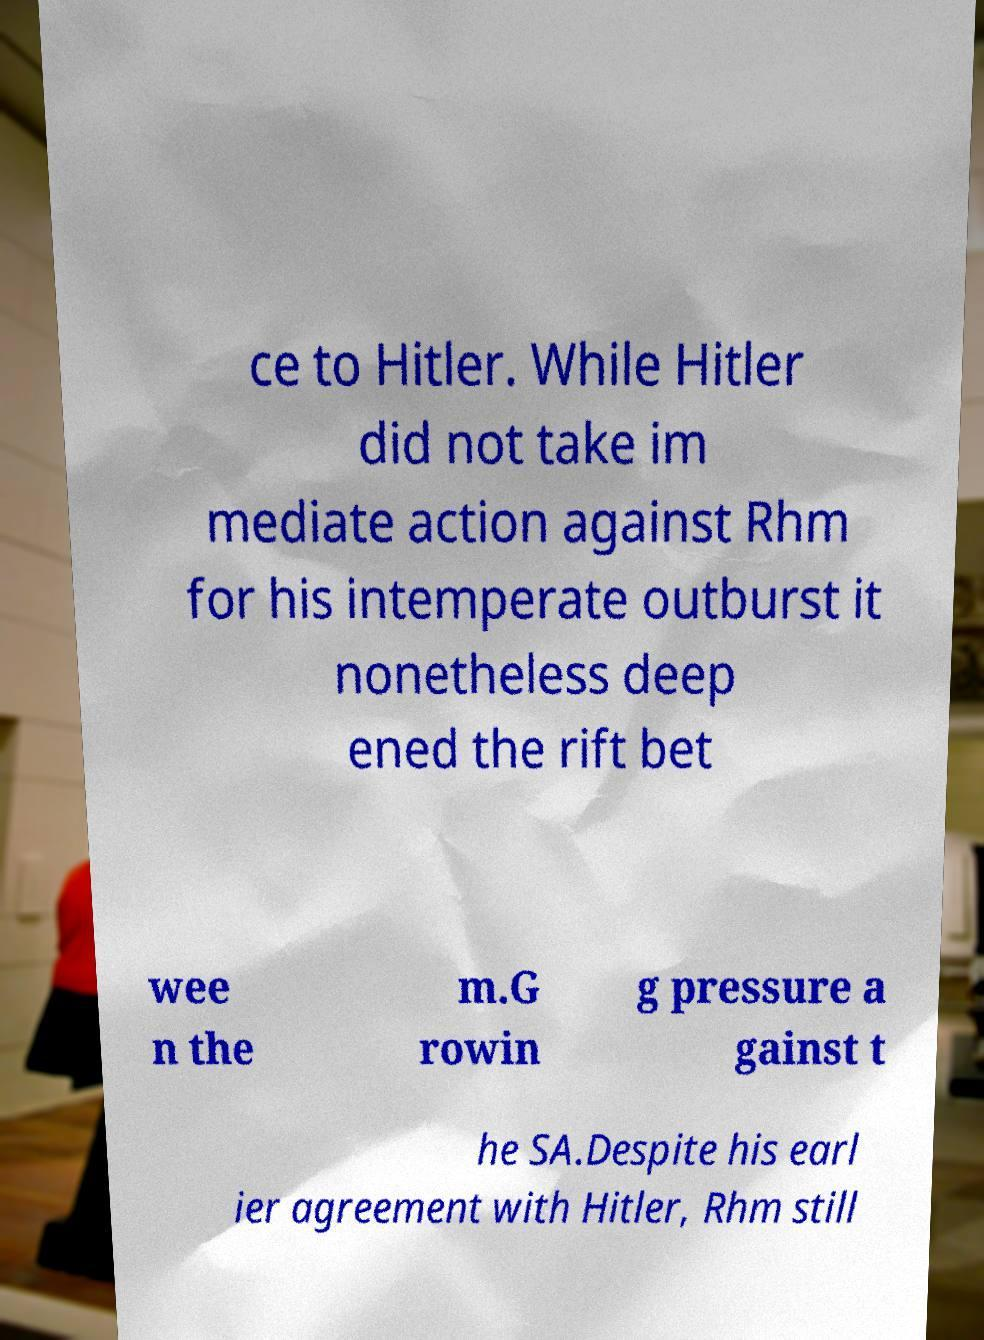There's text embedded in this image that I need extracted. Can you transcribe it verbatim? ce to Hitler. While Hitler did not take im mediate action against Rhm for his intemperate outburst it nonetheless deep ened the rift bet wee n the m.G rowin g pressure a gainst t he SA.Despite his earl ier agreement with Hitler, Rhm still 